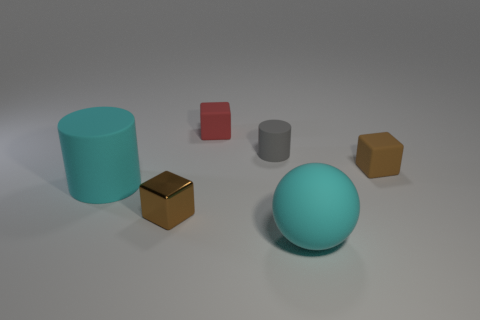There is another shiny cube that is the same size as the red block; what color is it?
Your response must be concise. Brown. How many cyan shiny objects are the same shape as the small red object?
Ensure brevity in your answer.  0. Does the cyan matte ball have the same size as the cyan thing left of the red matte object?
Give a very brief answer. Yes. What shape is the small brown object in front of the large rubber object behind the metal cube?
Provide a short and direct response. Cube. Is the number of brown rubber blocks behind the cyan cylinder less than the number of big cyan shiny balls?
Offer a very short reply. No. The other tiny thing that is the same color as the tiny shiny object is what shape?
Offer a very short reply. Cube. What number of red rubber blocks have the same size as the brown rubber block?
Keep it short and to the point. 1. There is a cyan rubber object that is right of the gray matte thing; what is its shape?
Provide a succinct answer. Sphere. Are there fewer big cyan things than rubber things?
Your answer should be very brief. Yes. Is there any other thing of the same color as the big ball?
Your answer should be compact. Yes. 